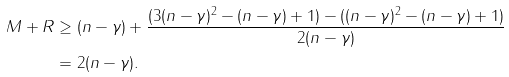Convert formula to latex. <formula><loc_0><loc_0><loc_500><loc_500>M + R & \geq ( n - \gamma ) + \frac { ( 3 ( n - \gamma ) ^ { 2 } - ( n - \gamma ) + 1 ) - ( ( n - \gamma ) ^ { 2 } - ( n - \gamma ) + 1 ) } { 2 ( n - \gamma ) } \\ & = 2 ( n - \gamma ) .</formula> 